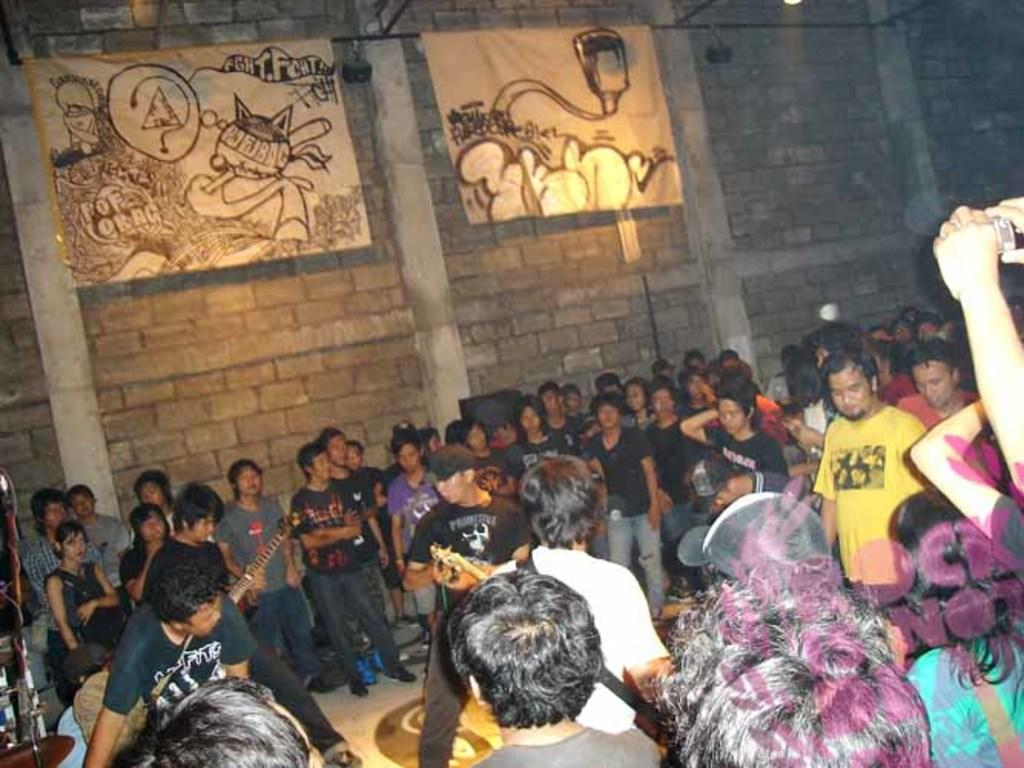What can be seen in the image? There are people standing in the image. Where are the people located? The people are in an area. What is on the wall in the image? There are posters on the wall in the image. What type of fork is being used by the people in the image? There is no fork present in the image; the people are standing without any visible utensils. 